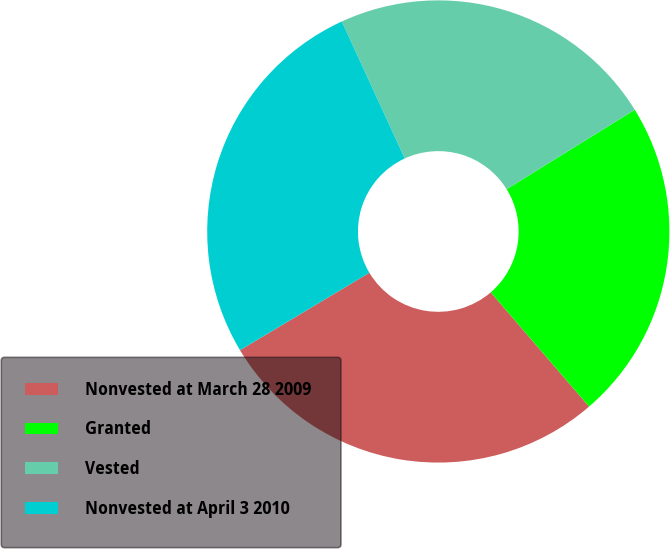Convert chart to OTSL. <chart><loc_0><loc_0><loc_500><loc_500><pie_chart><fcel>Nonvested at March 28 2009<fcel>Granted<fcel>Vested<fcel>Nonvested at April 3 2010<nl><fcel>27.73%<fcel>22.51%<fcel>23.03%<fcel>26.73%<nl></chart> 